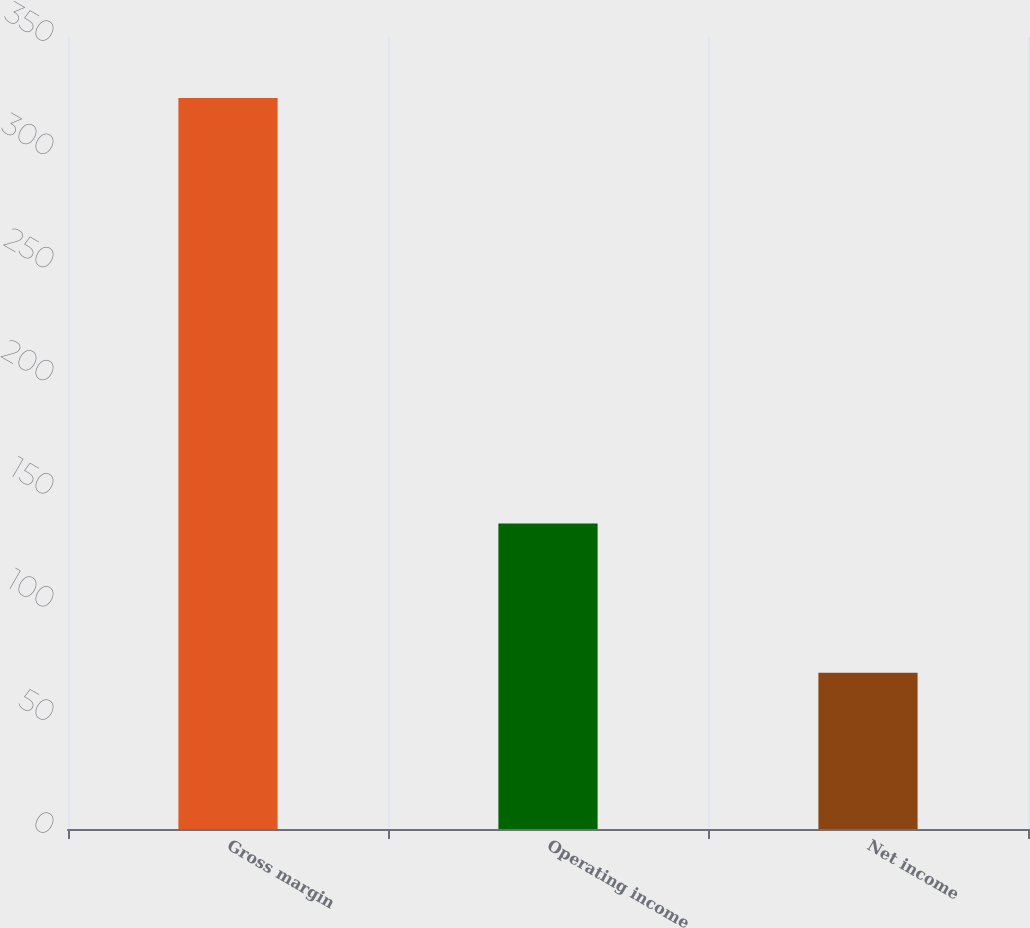<chart> <loc_0><loc_0><loc_500><loc_500><bar_chart><fcel>Gross margin<fcel>Operating income<fcel>Net income<nl><fcel>323<fcel>135<fcel>69<nl></chart> 